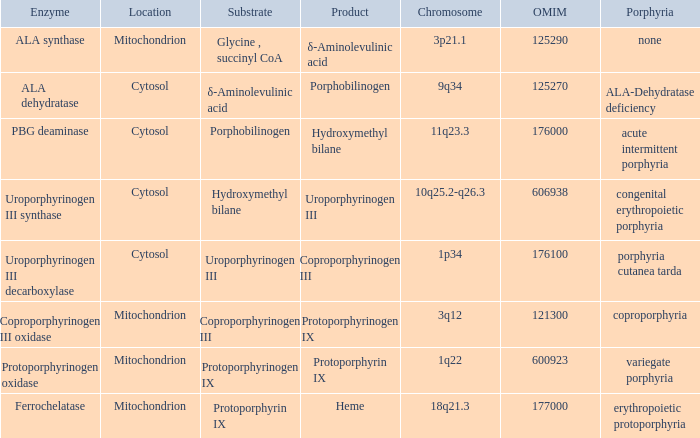What is protoporphyrin ix's substrate? Protoporphyrinogen IX. 